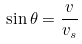<formula> <loc_0><loc_0><loc_500><loc_500>\sin \theta = \frac { v } { v _ { s } }</formula> 